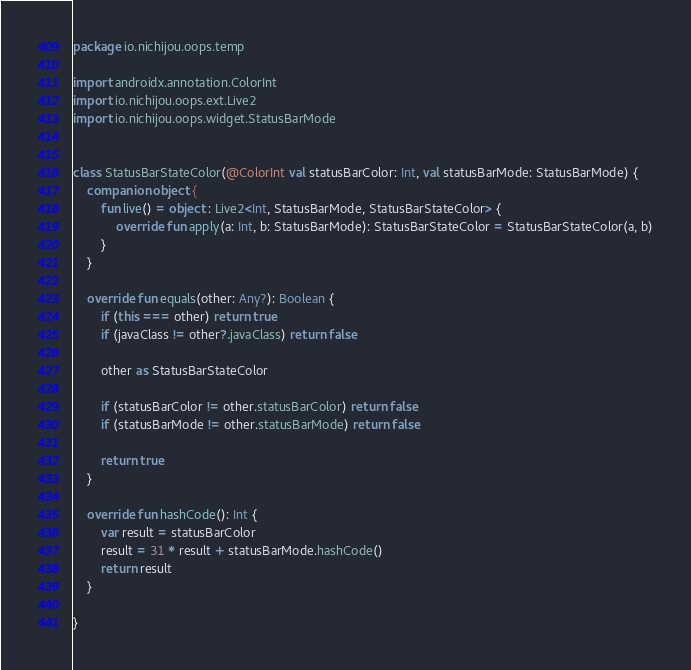Convert code to text. <code><loc_0><loc_0><loc_500><loc_500><_Kotlin_>package io.nichijou.oops.temp

import androidx.annotation.ColorInt
import io.nichijou.oops.ext.Live2
import io.nichijou.oops.widget.StatusBarMode


class StatusBarStateColor(@ColorInt val statusBarColor: Int, val statusBarMode: StatusBarMode) {
    companion object {
        fun live() = object : Live2<Int, StatusBarMode, StatusBarStateColor> {
            override fun apply(a: Int, b: StatusBarMode): StatusBarStateColor = StatusBarStateColor(a, b)
        }
    }

    override fun equals(other: Any?): Boolean {
        if (this === other) return true
        if (javaClass != other?.javaClass) return false

        other as StatusBarStateColor

        if (statusBarColor != other.statusBarColor) return false
        if (statusBarMode != other.statusBarMode) return false

        return true
    }

    override fun hashCode(): Int {
        var result = statusBarColor
        result = 31 * result + statusBarMode.hashCode()
        return result
    }

}
</code> 